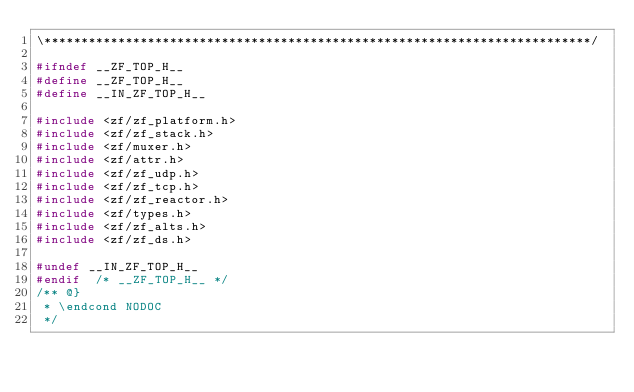<code> <loc_0><loc_0><loc_500><loc_500><_C_>\**************************************************************************/

#ifndef __ZF_TOP_H__
#define __ZF_TOP_H__
#define __IN_ZF_TOP_H__

#include <zf/zf_platform.h>
#include <zf/zf_stack.h>
#include <zf/muxer.h>
#include <zf/attr.h>
#include <zf/zf_udp.h>
#include <zf/zf_tcp.h>
#include <zf/zf_reactor.h>
#include <zf/types.h>
#include <zf/zf_alts.h>
#include <zf/zf_ds.h>

#undef __IN_ZF_TOP_H__
#endif  /* __ZF_TOP_H__ */
/** @}
 * \endcond NODOC
 */
</code> 